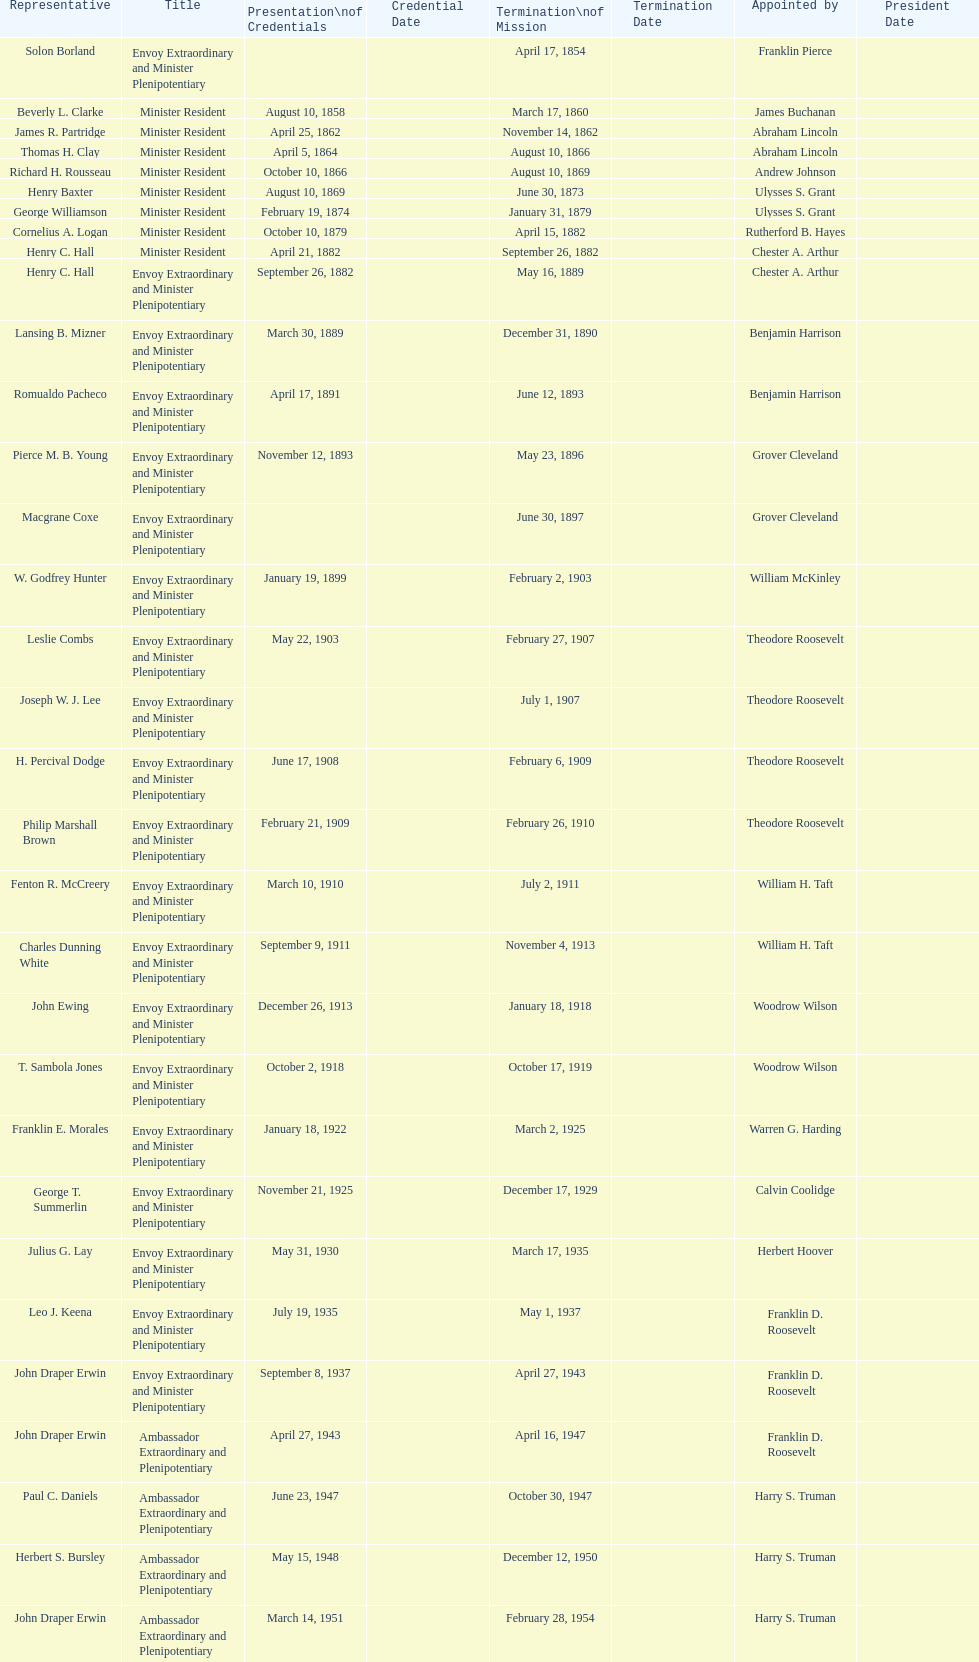Which diplomatic representative to honduras served the most extended term? Henry C. Hall. 